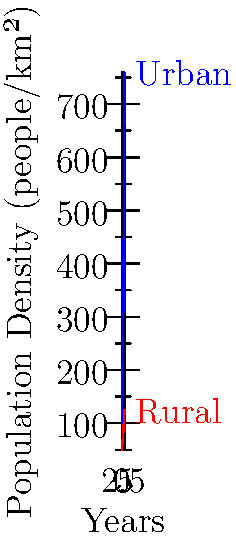The graph shows the population density trends in urban and rural areas of a Ugandan district over 5 years. If the district has a fixed number of 10 sexual health clinics, and each clinic can effectively serve 100 people per km², by how much should the number of clinics in urban areas increase by year 5 to maintain the same level of service as in year 0? To solve this problem, we need to follow these steps:

1. Calculate the total area that can be served by 10 clinics:
   $10 \text{ clinics} \times 100 \text{ people/km²/clinic} = 1000 \text{ people/km²}$

2. Find the urban population density in year 0:
   From the graph, we can see that it's 100 people/km².

3. Find the urban population density in year 5:
   From the graph, we can see that it's 759 people/km².

4. Calculate the increase in population density:
   $759 \text{ people/km²} - 100 \text{ people/km²} = 659 \text{ people/km²}$

5. Calculate the number of additional clinics needed:
   $\frac{659 \text{ people/km²}}{100 \text{ people/km²/clinic}} = 6.59 \text{ clinics}$

6. Round up to the nearest whole number:
   7 additional clinics are needed.

Therefore, the number of clinics in urban areas should increase by 7 by year 5 to maintain the same level of service as in year 0.
Answer: 7 clinics 